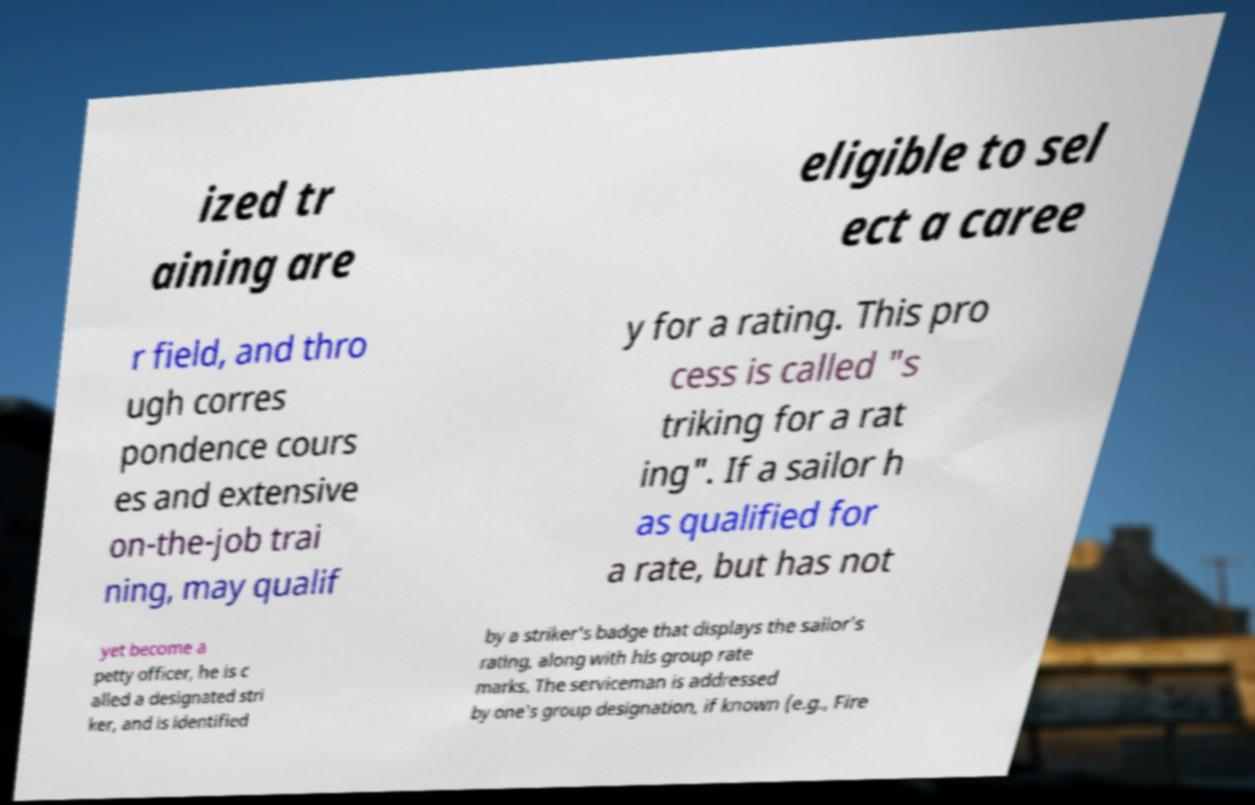Could you assist in decoding the text presented in this image and type it out clearly? ized tr aining are eligible to sel ect a caree r field, and thro ugh corres pondence cours es and extensive on-the-job trai ning, may qualif y for a rating. This pro cess is called "s triking for a rat ing". If a sailor h as qualified for a rate, but has not yet become a petty officer, he is c alled a designated stri ker, and is identified by a striker's badge that displays the sailor's rating, along with his group rate marks. The serviceman is addressed by one's group designation, if known (e.g., Fire 